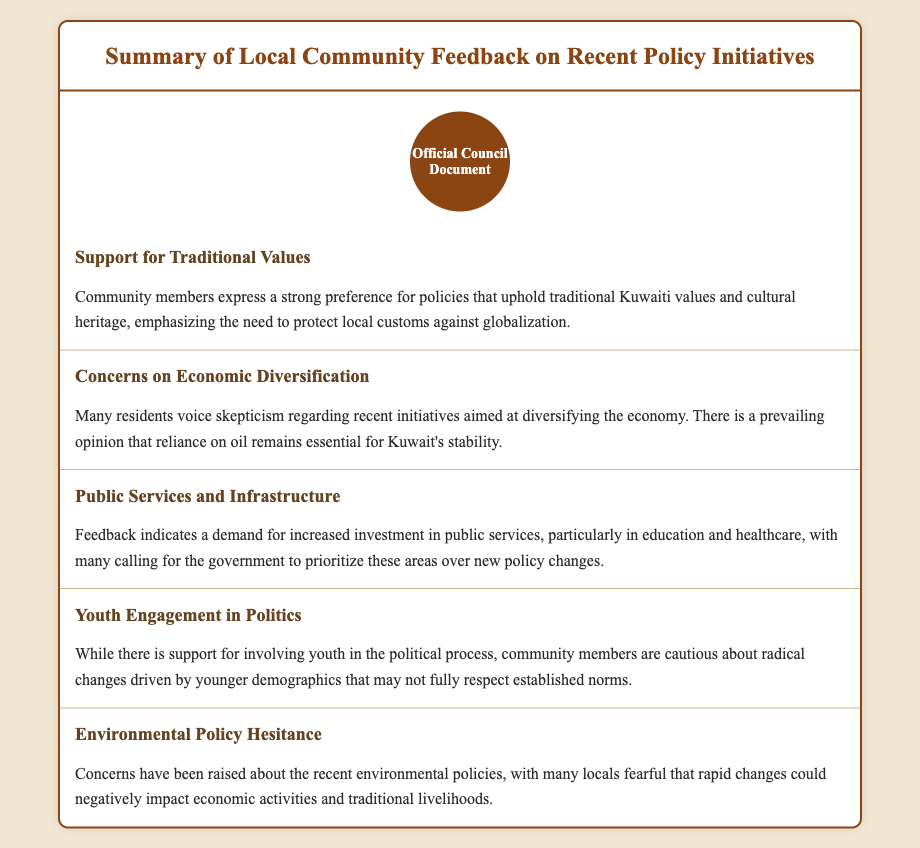What is the title of the document? The title is stated in the header of the document, summarizing the content it covers.
Answer: Summary of Local Community Feedback on Recent Policy Initiatives What is the first key theme highlighted? The first key theme is presented in the document's sections, specifically focusing on community values.
Answer: Support for Traditional Values Which service is emphasized for increased investment? The document lists specific areas where community feedback calls for government prioritization.
Answer: Education and healthcare What is the community's viewpoint on economic diversification? The section discusses residents' feelings towards economic initiatives and stability concerns.
Answer: Skepticism What do locals fear regarding environmental policies? Concerns mentioned in the document relate to the impact of policies on livelihoods and economic activities.
Answer: Negative impact How do community members feel about youth engagement in politics? The feedback reflects cautious optimism but highlights concerns about respect for norms.
Answer: Cautious What underlying theme is mentioned about globalization? The theme discusses the community's perspective on maintaining cultural heritage.
Answer: Protect local customs Which demographic is mentioned in relation to political changes? The document indicates a specific focus on a generational group’s involvement.
Answer: Youth 